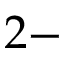Convert formula to latex. <formula><loc_0><loc_0><loc_500><loc_500>2 -</formula> 